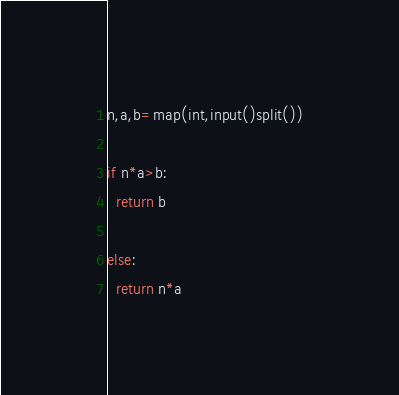Convert code to text. <code><loc_0><loc_0><loc_500><loc_500><_Python_>n,a,b=map(int,input()split())

if n*a>b:
  return b

else:
  return n*a</code> 